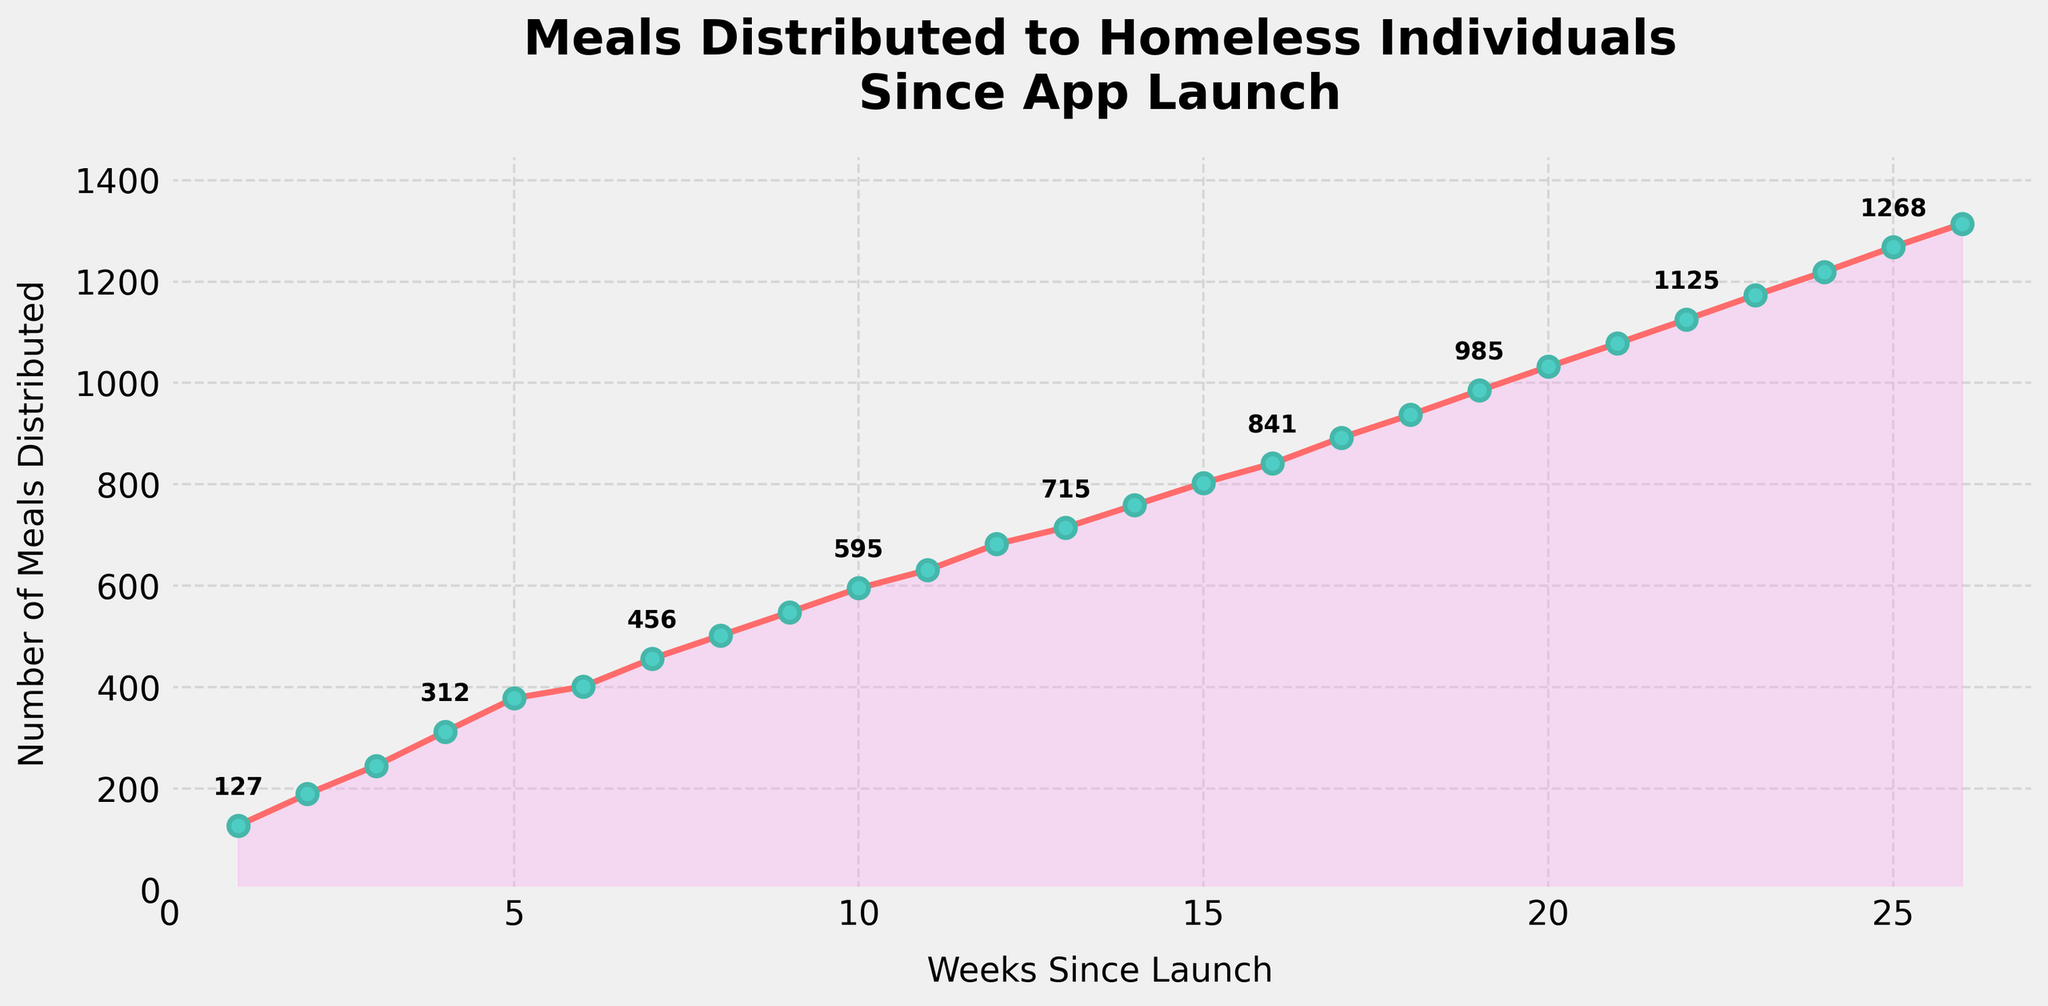What is the total number of meals distributed by week 10? Sum the number of meals distributed each week up to week 10: 127 + 189 + 245 + 312 + 378 + 401 + 456 + 502 + 548 + 595 = 3,753
Answer: 3,753 During which week did the number of meals distributed first exceed 500? Scan the plotted line and data points for the first week where the number of meals distributed exceeds 500. By visual inspection of the point labels, week 8 first exceeds 500 with 502 meals.
Answer: Week 8 What is the difference in the number of meals distributed between week 15 and week 10? Subtract the number of meals distributed in week 10 from the number in week 15: 803 - 595 = 208
Answer: 208 How many weeks did it take for the number of meals distributed to double from week 5 levels? The number of meals in week 5 is 378. Find the week where this number doubles (i.e., 2 x 378 = 756). Check the figures: By week 14, there are 759 meals distributed, which is more than double 378. Therefore, it took 14 - 5 = 9 weeks.
Answer: 9 Which week showed the highest number of meals distributed? Visually inspect the plotted line for the highest data point. The highest data point corresponds to week 26 with 1,314 meals.
Answer: Week 26 How much did the number of meals distributed increase from week 1 to week 26? Subtract the number of meals in week 1 from the number in week 26: 1,314 - 127 = 1,187
Answer: 1,187 What is the average number of meals distributed per week in the first 6 weeks? Sum the meals for the first 6 weeks and divide by 6: (127 + 189 + 245 + 312 + 378 + 401)/6 = 1,652/6 = 275.33
Answer: 275.33 How does the number of meals distributed in week 18 compare to week 6? Look at the figures: Week 18 has 937 meals and week 6 has 401 meals. Subtract 401 from 937: 937 - 401 = 536
Answer: 536 more in week 18 Did the number of meals distributed increase every week? Visually inspect the plotted line. Each week's data point is higher than the previous week's, indicating a continuous increase in the number of meals distributed each week
Answer: Yes What is the steepest rise in the number of meals distributed from one week to the next? Calculate the differences between consecutive weeks: Max increase occurs between week 19 (985) and week 20 (1,032), an increase of 47
Answer: Week 19 to Week 20 